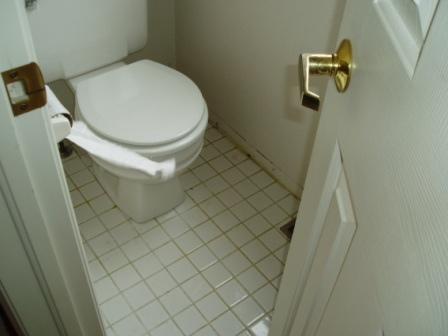What type of metal is the flooring?
Write a very short answer. Tile. Would it be good to close the door when you're in this room?
Be succinct. Yes. Are wires visible?
Concise answer only. No. Is this bathroom clean?
Be succinct. Yes. Is there enough toilet paper for the next person?
Short answer required. No. 